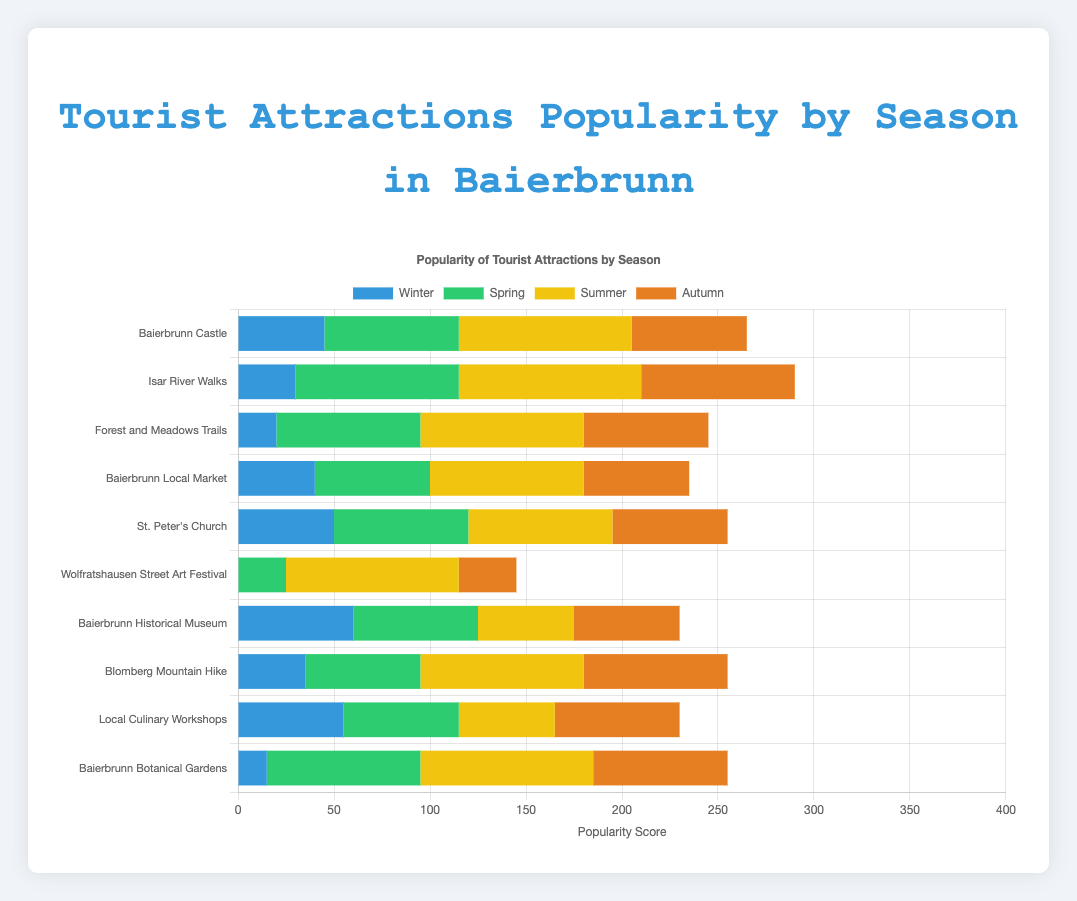Which attraction has the highest popularity in Summer? To find the attraction with the highest popularity in Summer, we need to compare the Summer values for all attractions. The data shows that Isar River Walks has a popularity of 95 in Summer, which is the highest among all attractions.
Answer: Isar River Walks Which season does Baierbrunn Castle have the lowest popularity? To determine the season where Baierbrunn Castle has the lowest popularity, compare its popularity across seasons. The data shows: Winter (45), Spring (70), Summer (90), Autumn (60). Winter has the lowest score at 45.
Answer: Winter What is the combined popularity of St. Peter's Church in Winter and Spring? To find the combined popularity, add the values for Winter and Spring for St. Peter's Church. The data shows Winter (50) and Spring (70), so 50 + 70 = 120.
Answer: 120 Which attraction has the lowest popularity in Winter? To find the attraction with the lowest Winter popularity, compare the Winter values for all attractions. Wolfratshausen Street Art Festival has the lowest score at 0.
Answer: Wolfratshausen Street Art Festival Compare the popularity of Baierbrunn Local Market in Summer and Autumn, which one is higher? To compare the popularity in Summer and Autumn for Baierbrunn Local Market, look at the values: Summer (80) and Autumn (55). Summer has a higher value.
Answer: Summer What’s the total popularity of Forest and Meadows Trails across all seasons? To find the total popularity across all seasons for Forest and Meadows Trails, add up the values from all seasons. Winter (20) + Spring (75) + Summer (85) + Autumn (65) = 245.
Answer: 245 Which attraction has a popularity score of 85 in Spring? To find the attraction with a popularity score of 85 in Spring, check the Spring values for all attractions. Isar River Walks has a Spring score of 85.
Answer: Isar River Walks What is the highest popularity score for Baierbrunn Historical Museum across all seasons? To find the highest score for Baierbrunn Historical Museum, compare the values for each season. Winter (60), Spring (65), Summer (50), Autumn (55). The highest score is 65 in Spring.
Answer: 65 Which season has the highest popularity for Forest and Meadows Trails? To determine the season with the highest popularity for Forest and Meadows Trails, compare the values for each season. Winter (20), Spring (75), Summer (85), Autumn (65). The highest is Summer with 85.
Answer: Summer Compare the combined popularity of Baierbrunn Botanical Gardens in Winter and Spring to its popularity in Summer. Is the combined value higher or lower? First, find the combined popularity in Winter and Spring: Winter (15) + Spring (80) = 95. Then compare it to the Summer value: 90. The combined value (95) is higher.
Answer: Higher 